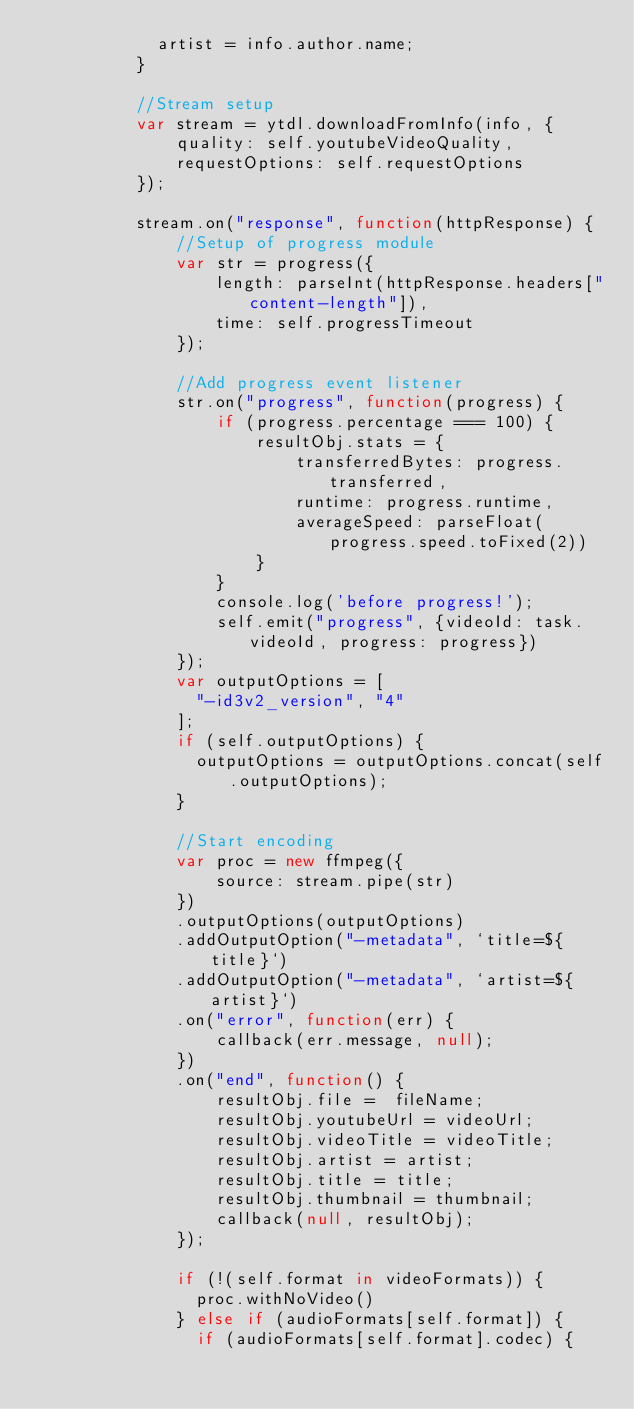Convert code to text. <code><loc_0><loc_0><loc_500><loc_500><_JavaScript_>            artist = info.author.name;
          }

          //Stream setup
          var stream = ytdl.downloadFromInfo(info, {
              quality: self.youtubeVideoQuality,
              requestOptions: self.requestOptions
          });

          stream.on("response", function(httpResponse) {
              //Setup of progress module
              var str = progress({
                  length: parseInt(httpResponse.headers["content-length"]),
                  time: self.progressTimeout
              });

              //Add progress event listener
              str.on("progress", function(progress) {
                  if (progress.percentage === 100) {
                      resultObj.stats = {
                          transferredBytes: progress.transferred,
                          runtime: progress.runtime,
                          averageSpeed: parseFloat(progress.speed.toFixed(2))
                      }
                  }
                  console.log('before progress!');
                  self.emit("progress", {videoId: task.videoId, progress: progress})
              });
              var outputOptions = [
                "-id3v2_version", "4"
              ];
              if (self.outputOptions) {
                outputOptions = outputOptions.concat(self.outputOptions);
              }

              //Start encoding
              var proc = new ffmpeg({
                  source: stream.pipe(str)
              })
              .outputOptions(outputOptions)
              .addOutputOption("-metadata", `title=${title}`)
              .addOutputOption("-metadata", `artist=${artist}`)
              .on("error", function(err) {
                  callback(err.message, null);
              })
              .on("end", function() {
                  resultObj.file =  fileName;
                  resultObj.youtubeUrl = videoUrl;
                  resultObj.videoTitle = videoTitle;
                  resultObj.artist = artist;
                  resultObj.title = title;
                  resultObj.thumbnail = thumbnail;
                  callback(null, resultObj);
              });

              if (!(self.format in videoFormats)) {
                proc.withNoVideo()
              } else if (audioFormats[self.format]) {
                if (audioFormats[self.format].codec) {</code> 